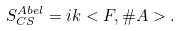<formula> <loc_0><loc_0><loc_500><loc_500>S ^ { A b e l } _ { C S } = i k < F , \# A > .</formula> 